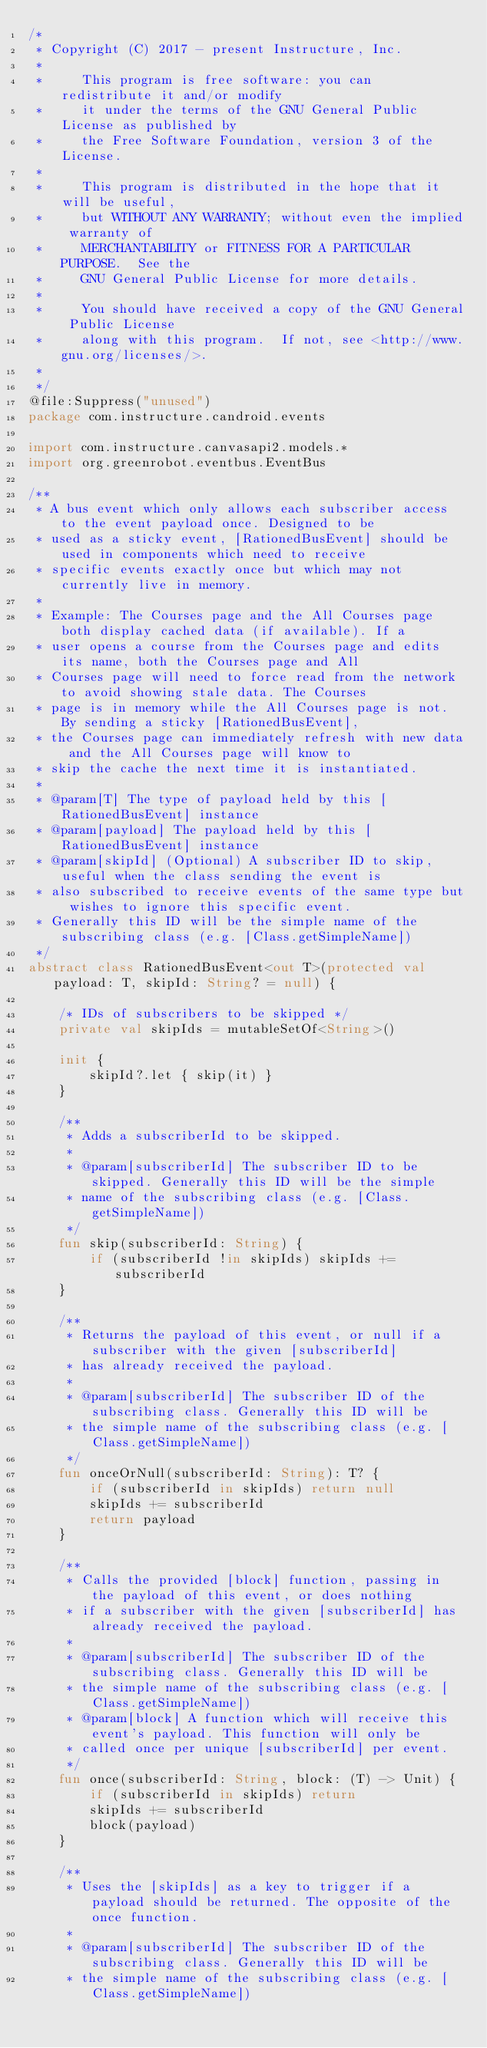Convert code to text. <code><loc_0><loc_0><loc_500><loc_500><_Kotlin_>/*
 * Copyright (C) 2017 - present Instructure, Inc.
 *
 *     This program is free software: you can redistribute it and/or modify
 *     it under the terms of the GNU General Public License as published by
 *     the Free Software Foundation, version 3 of the License.
 *
 *     This program is distributed in the hope that it will be useful,
 *     but WITHOUT ANY WARRANTY; without even the implied warranty of
 *     MERCHANTABILITY or FITNESS FOR A PARTICULAR PURPOSE.  See the
 *     GNU General Public License for more details.
 *
 *     You should have received a copy of the GNU General Public License
 *     along with this program.  If not, see <http://www.gnu.org/licenses/>.
 *
 */
@file:Suppress("unused")
package com.instructure.candroid.events

import com.instructure.canvasapi2.models.*
import org.greenrobot.eventbus.EventBus

/**
 * A bus event which only allows each subscriber access to the event payload once. Designed to be
 * used as a sticky event, [RationedBusEvent] should be used in components which need to receive
 * specific events exactly once but which may not currently live in memory.
 *
 * Example: The Courses page and the All Courses page both display cached data (if available). If a
 * user opens a course from the Courses page and edits its name, both the Courses page and All
 * Courses page will need to force read from the network to avoid showing stale data. The Courses
 * page is in memory while the All Courses page is not. By sending a sticky [RationedBusEvent],
 * the Courses page can immediately refresh with new data and the All Courses page will know to
 * skip the cache the next time it is instantiated.
 *
 * @param[T] The type of payload held by this [RationedBusEvent] instance
 * @param[payload] The payload held by this [RationedBusEvent] instance
 * @param[skipId] (Optional) A subscriber ID to skip, useful when the class sending the event is
 * also subscribed to receive events of the same type but wishes to ignore this specific event.
 * Generally this ID will be the simple name of the subscribing class (e.g. [Class.getSimpleName])
 */
abstract class RationedBusEvent<out T>(protected val payload: T, skipId: String? = null) {

    /* IDs of subscribers to be skipped */
    private val skipIds = mutableSetOf<String>()

    init {
        skipId?.let { skip(it) }
    }

    /**
     * Adds a subscriberId to be skipped.
     *
     * @param[subscriberId] The subscriber ID to be skipped. Generally this ID will be the simple
     * name of the subscribing class (e.g. [Class.getSimpleName])
     */
    fun skip(subscriberId: String) {
        if (subscriberId !in skipIds) skipIds += subscriberId
    }

    /**
     * Returns the payload of this event, or null if a subscriber with the given [subscriberId]
     * has already received the payload.
     *
     * @param[subscriberId] The subscriber ID of the subscribing class. Generally this ID will be
     * the simple name of the subscribing class (e.g. [Class.getSimpleName])
     */
    fun onceOrNull(subscriberId: String): T? {
        if (subscriberId in skipIds) return null
        skipIds += subscriberId
        return payload
    }

    /**
     * Calls the provided [block] function, passing in the payload of this event, or does nothing
     * if a subscriber with the given [subscriberId] has already received the payload.
     *
     * @param[subscriberId] The subscriber ID of the subscribing class. Generally this ID will be
     * the simple name of the subscribing class (e.g. [Class.getSimpleName])
     * @param[block] A function which will receive this event's payload. This function will only be
     * called once per unique [subscriberId] per event.
     */
    fun once(subscriberId: String, block: (T) -> Unit) {
        if (subscriberId in skipIds) return
        skipIds += subscriberId
        block(payload)
    }

    /**
     * Uses the [skipIds] as a key to trigger if a payload should be returned. The opposite of the once function.
     *
     * @param[subscriberId] The subscriber ID of the subscribing class. Generally this ID will be
     * the simple name of the subscribing class (e.g. [Class.getSimpleName])</code> 